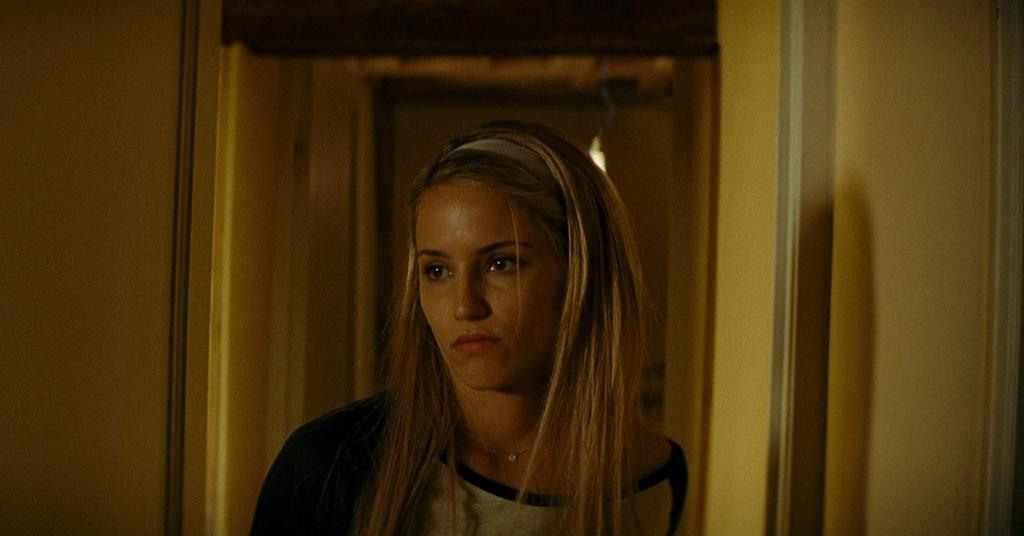Who is present in the image? There is a lady in the image. What type of structure can be seen in the image? Walls are visible in the image. Can you describe the lighting in the image? There is light in the image. What type of vacation is the lady enjoying in the image? There is no indication of a vacation in the image; it only shows a lady and walls with light. 